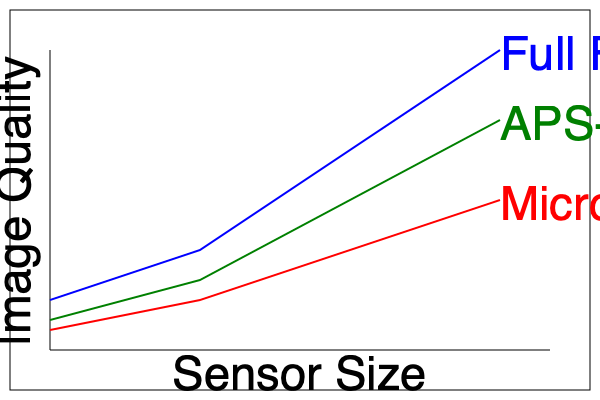As a nature photographer, you're considering upgrading your camera. Based on the graph, which sensor size would provide the best image quality for capturing detailed close-ups of flowers while minimizing the risk of encountering insects? Explain your reasoning. To answer this question, let's analyze the graph step-by-step:

1. The graph shows the relationship between sensor size and image quality for three different sensor types: Full Frame, APS-C, and Micro Four Thirds.

2. The y-axis represents image quality, with higher values indicating better quality.

3. The x-axis represents sensor size, with larger sizes to the right.

4. Observing the lines:
   - Blue line (Full Frame): Shows the highest image quality across all sensor sizes.
   - Green line (APS-C): Shows good image quality, but slightly lower than Full Frame.
   - Red line (Micro Four Thirds): Shows the lowest image quality of the three.

5. For capturing detailed close-ups of flowers:
   - Higher image quality is crucial for capturing fine details.
   - Larger sensors generally provide better low-light performance and dynamic range.

6. Considering the mild fear of insects:
   - Larger sensors typically require you to be closer to the subject for the same field of view.
   - A smaller sensor allows for a greater working distance, reducing the chance of encountering insects up close.

7. Balancing these factors:
   - Full Frame offers the best image quality but may require getting too close to the subject.
   - Micro Four Thirds provides the greatest working distance but at the cost of image quality.
   - APS-C offers a good compromise between image quality and working distance.

Therefore, the APS-C sensor would be the best choice for this scenario. It provides better image quality than Micro Four Thirds while allowing for a greater working distance than Full Frame, reducing the risk of close encounters with insects.
Answer: APS-C sensor 